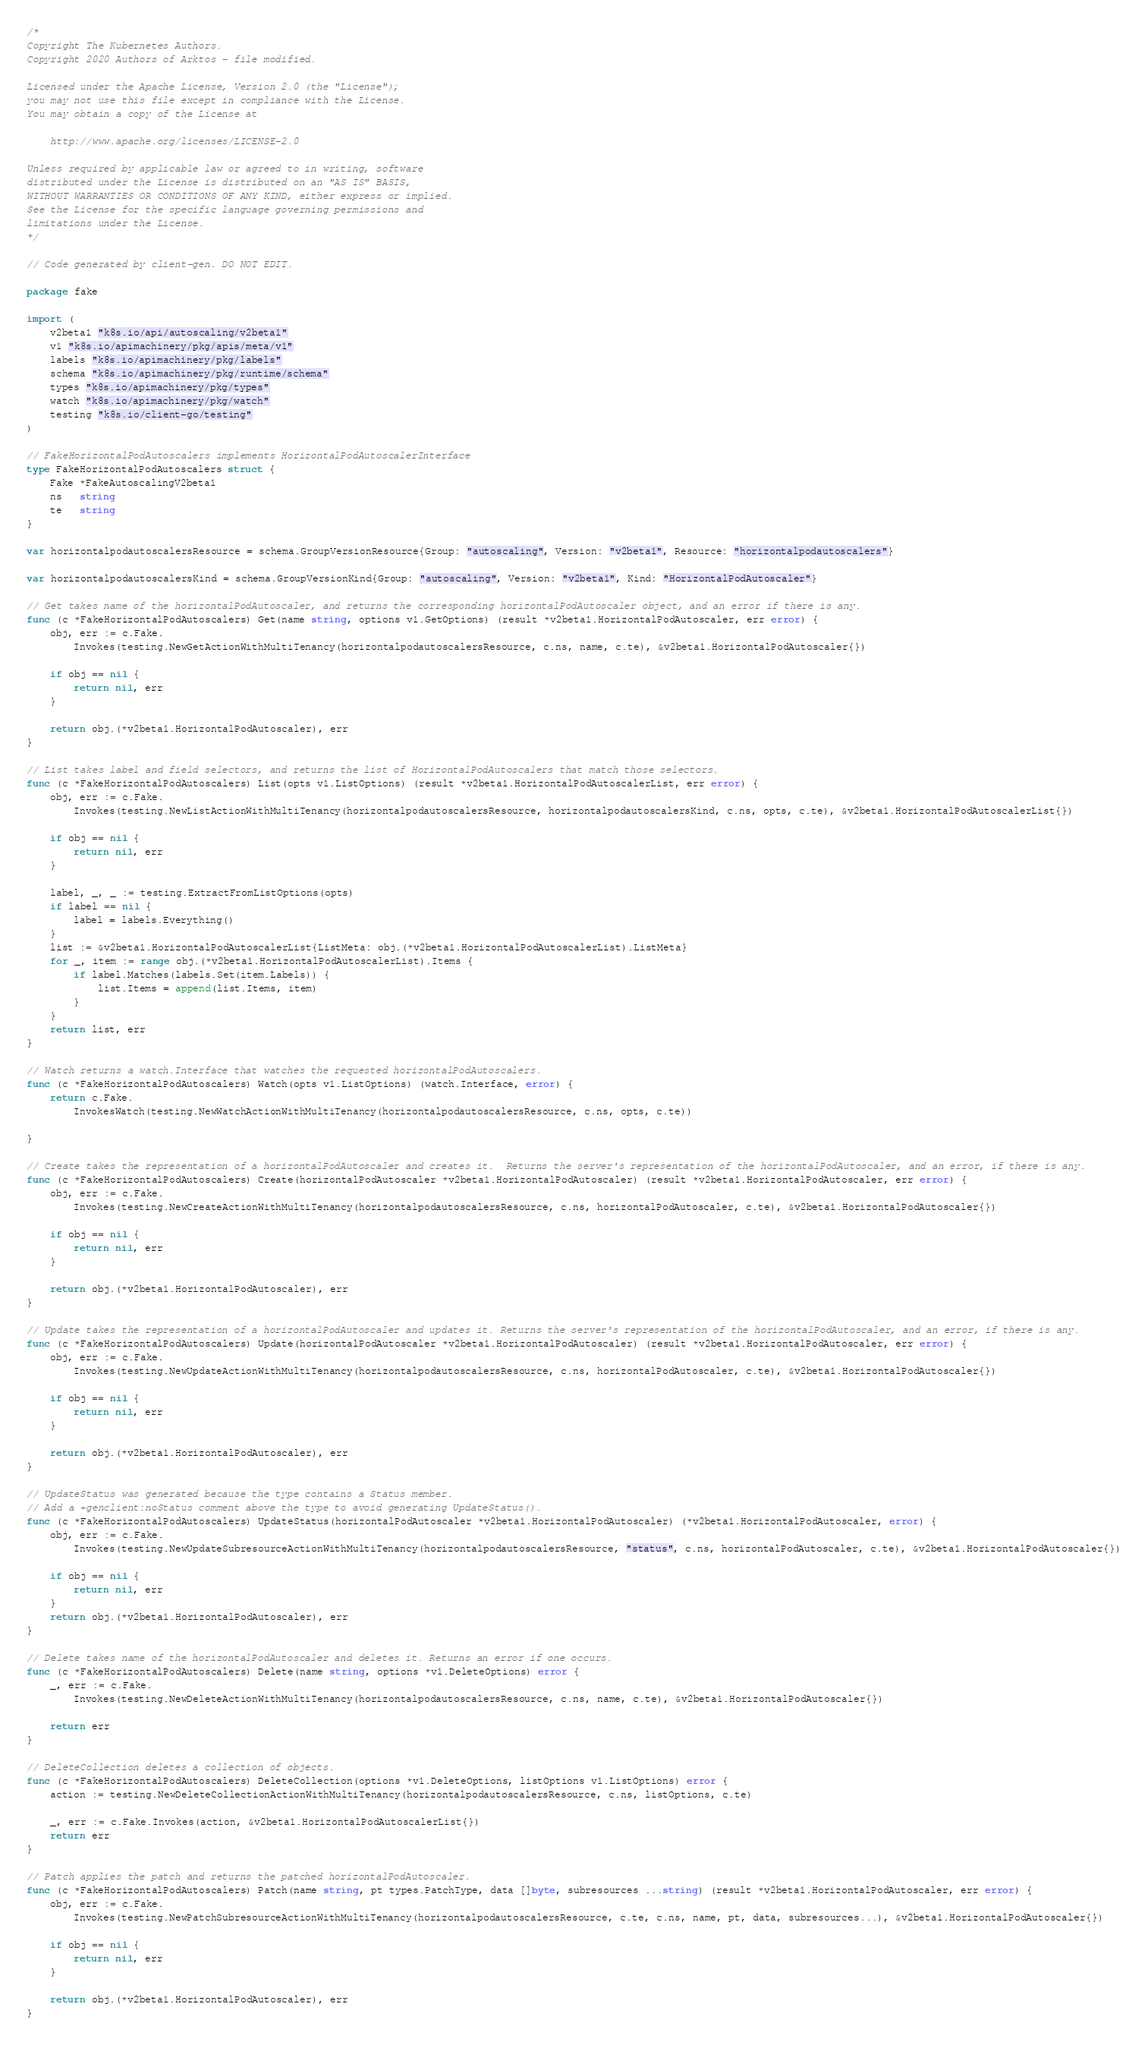Convert code to text. <code><loc_0><loc_0><loc_500><loc_500><_Go_>/*
Copyright The Kubernetes Authors.
Copyright 2020 Authors of Arktos - file modified.

Licensed under the Apache License, Version 2.0 (the "License");
you may not use this file except in compliance with the License.
You may obtain a copy of the License at

    http://www.apache.org/licenses/LICENSE-2.0

Unless required by applicable law or agreed to in writing, software
distributed under the License is distributed on an "AS IS" BASIS,
WITHOUT WARRANTIES OR CONDITIONS OF ANY KIND, either express or implied.
See the License for the specific language governing permissions and
limitations under the License.
*/

// Code generated by client-gen. DO NOT EDIT.

package fake

import (
	v2beta1 "k8s.io/api/autoscaling/v2beta1"
	v1 "k8s.io/apimachinery/pkg/apis/meta/v1"
	labels "k8s.io/apimachinery/pkg/labels"
	schema "k8s.io/apimachinery/pkg/runtime/schema"
	types "k8s.io/apimachinery/pkg/types"
	watch "k8s.io/apimachinery/pkg/watch"
	testing "k8s.io/client-go/testing"
)

// FakeHorizontalPodAutoscalers implements HorizontalPodAutoscalerInterface
type FakeHorizontalPodAutoscalers struct {
	Fake *FakeAutoscalingV2beta1
	ns   string
	te   string
}

var horizontalpodautoscalersResource = schema.GroupVersionResource{Group: "autoscaling", Version: "v2beta1", Resource: "horizontalpodautoscalers"}

var horizontalpodautoscalersKind = schema.GroupVersionKind{Group: "autoscaling", Version: "v2beta1", Kind: "HorizontalPodAutoscaler"}

// Get takes name of the horizontalPodAutoscaler, and returns the corresponding horizontalPodAutoscaler object, and an error if there is any.
func (c *FakeHorizontalPodAutoscalers) Get(name string, options v1.GetOptions) (result *v2beta1.HorizontalPodAutoscaler, err error) {
	obj, err := c.Fake.
		Invokes(testing.NewGetActionWithMultiTenancy(horizontalpodautoscalersResource, c.ns, name, c.te), &v2beta1.HorizontalPodAutoscaler{})

	if obj == nil {
		return nil, err
	}

	return obj.(*v2beta1.HorizontalPodAutoscaler), err
}

// List takes label and field selectors, and returns the list of HorizontalPodAutoscalers that match those selectors.
func (c *FakeHorizontalPodAutoscalers) List(opts v1.ListOptions) (result *v2beta1.HorizontalPodAutoscalerList, err error) {
	obj, err := c.Fake.
		Invokes(testing.NewListActionWithMultiTenancy(horizontalpodautoscalersResource, horizontalpodautoscalersKind, c.ns, opts, c.te), &v2beta1.HorizontalPodAutoscalerList{})

	if obj == nil {
		return nil, err
	}

	label, _, _ := testing.ExtractFromListOptions(opts)
	if label == nil {
		label = labels.Everything()
	}
	list := &v2beta1.HorizontalPodAutoscalerList{ListMeta: obj.(*v2beta1.HorizontalPodAutoscalerList).ListMeta}
	for _, item := range obj.(*v2beta1.HorizontalPodAutoscalerList).Items {
		if label.Matches(labels.Set(item.Labels)) {
			list.Items = append(list.Items, item)
		}
	}
	return list, err
}

// Watch returns a watch.Interface that watches the requested horizontalPodAutoscalers.
func (c *FakeHorizontalPodAutoscalers) Watch(opts v1.ListOptions) (watch.Interface, error) {
	return c.Fake.
		InvokesWatch(testing.NewWatchActionWithMultiTenancy(horizontalpodautoscalersResource, c.ns, opts, c.te))

}

// Create takes the representation of a horizontalPodAutoscaler and creates it.  Returns the server's representation of the horizontalPodAutoscaler, and an error, if there is any.
func (c *FakeHorizontalPodAutoscalers) Create(horizontalPodAutoscaler *v2beta1.HorizontalPodAutoscaler) (result *v2beta1.HorizontalPodAutoscaler, err error) {
	obj, err := c.Fake.
		Invokes(testing.NewCreateActionWithMultiTenancy(horizontalpodautoscalersResource, c.ns, horizontalPodAutoscaler, c.te), &v2beta1.HorizontalPodAutoscaler{})

	if obj == nil {
		return nil, err
	}

	return obj.(*v2beta1.HorizontalPodAutoscaler), err
}

// Update takes the representation of a horizontalPodAutoscaler and updates it. Returns the server's representation of the horizontalPodAutoscaler, and an error, if there is any.
func (c *FakeHorizontalPodAutoscalers) Update(horizontalPodAutoscaler *v2beta1.HorizontalPodAutoscaler) (result *v2beta1.HorizontalPodAutoscaler, err error) {
	obj, err := c.Fake.
		Invokes(testing.NewUpdateActionWithMultiTenancy(horizontalpodautoscalersResource, c.ns, horizontalPodAutoscaler, c.te), &v2beta1.HorizontalPodAutoscaler{})

	if obj == nil {
		return nil, err
	}

	return obj.(*v2beta1.HorizontalPodAutoscaler), err
}

// UpdateStatus was generated because the type contains a Status member.
// Add a +genclient:noStatus comment above the type to avoid generating UpdateStatus().
func (c *FakeHorizontalPodAutoscalers) UpdateStatus(horizontalPodAutoscaler *v2beta1.HorizontalPodAutoscaler) (*v2beta1.HorizontalPodAutoscaler, error) {
	obj, err := c.Fake.
		Invokes(testing.NewUpdateSubresourceActionWithMultiTenancy(horizontalpodautoscalersResource, "status", c.ns, horizontalPodAutoscaler, c.te), &v2beta1.HorizontalPodAutoscaler{})

	if obj == nil {
		return nil, err
	}
	return obj.(*v2beta1.HorizontalPodAutoscaler), err
}

// Delete takes name of the horizontalPodAutoscaler and deletes it. Returns an error if one occurs.
func (c *FakeHorizontalPodAutoscalers) Delete(name string, options *v1.DeleteOptions) error {
	_, err := c.Fake.
		Invokes(testing.NewDeleteActionWithMultiTenancy(horizontalpodautoscalersResource, c.ns, name, c.te), &v2beta1.HorizontalPodAutoscaler{})

	return err
}

// DeleteCollection deletes a collection of objects.
func (c *FakeHorizontalPodAutoscalers) DeleteCollection(options *v1.DeleteOptions, listOptions v1.ListOptions) error {
	action := testing.NewDeleteCollectionActionWithMultiTenancy(horizontalpodautoscalersResource, c.ns, listOptions, c.te)

	_, err := c.Fake.Invokes(action, &v2beta1.HorizontalPodAutoscalerList{})
	return err
}

// Patch applies the patch and returns the patched horizontalPodAutoscaler.
func (c *FakeHorizontalPodAutoscalers) Patch(name string, pt types.PatchType, data []byte, subresources ...string) (result *v2beta1.HorizontalPodAutoscaler, err error) {
	obj, err := c.Fake.
		Invokes(testing.NewPatchSubresourceActionWithMultiTenancy(horizontalpodautoscalersResource, c.te, c.ns, name, pt, data, subresources...), &v2beta1.HorizontalPodAutoscaler{})

	if obj == nil {
		return nil, err
	}

	return obj.(*v2beta1.HorizontalPodAutoscaler), err
}
</code> 